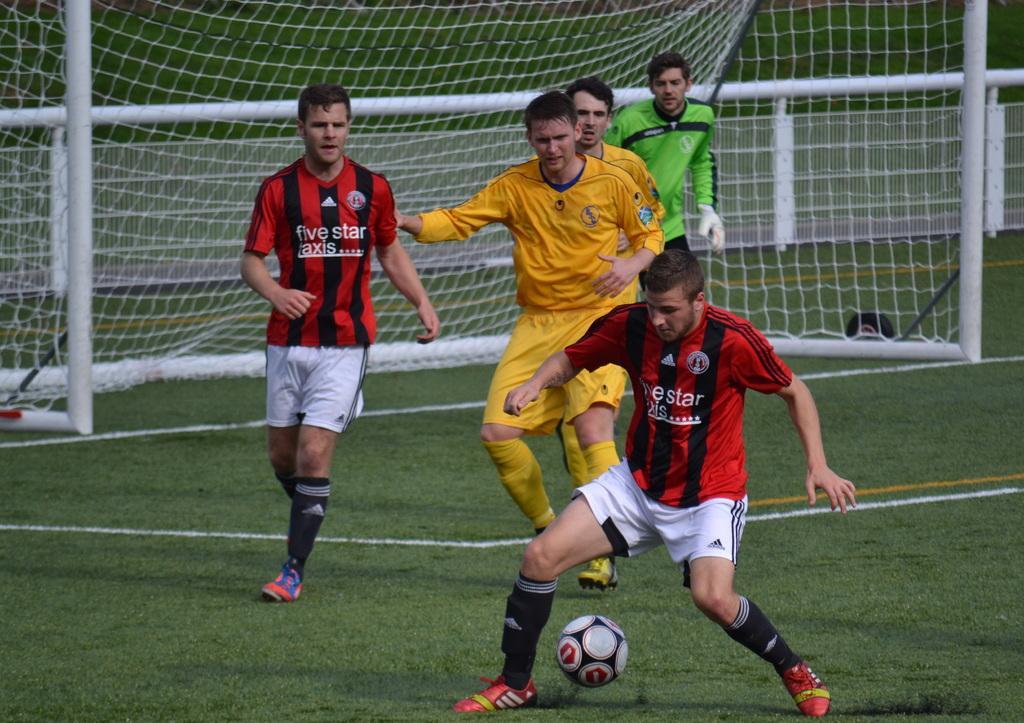Describe this image in one or two sentences. There are two teams in the ground playing a football with a ball. In the background there is a goalkeeper and a goal post here. 